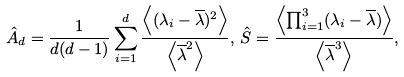<formula> <loc_0><loc_0><loc_500><loc_500>\hat { A } _ { d } = \frac { 1 } { d ( d - 1 ) } \sum _ { i = 1 } ^ { d } \frac { \left \langle ( \lambda _ { i } - { \overline { \lambda } } ) ^ { 2 } \right \rangle } { \left \langle \overline { \lambda } ^ { 2 } \right \rangle } , \, \hat { S } = \frac { \left \langle \prod _ { i = 1 } ^ { 3 } ( \lambda _ { i } - { \overline { \lambda } } ) \right \rangle } { \left \langle { \overline { \lambda } } ^ { 3 } \right \rangle } ,</formula> 